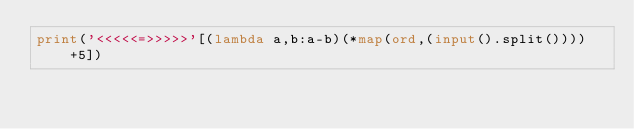<code> <loc_0><loc_0><loc_500><loc_500><_Python_>print('<<<<<=>>>>>'[(lambda a,b:a-b)(*map(ord,(input().split())))+5])</code> 